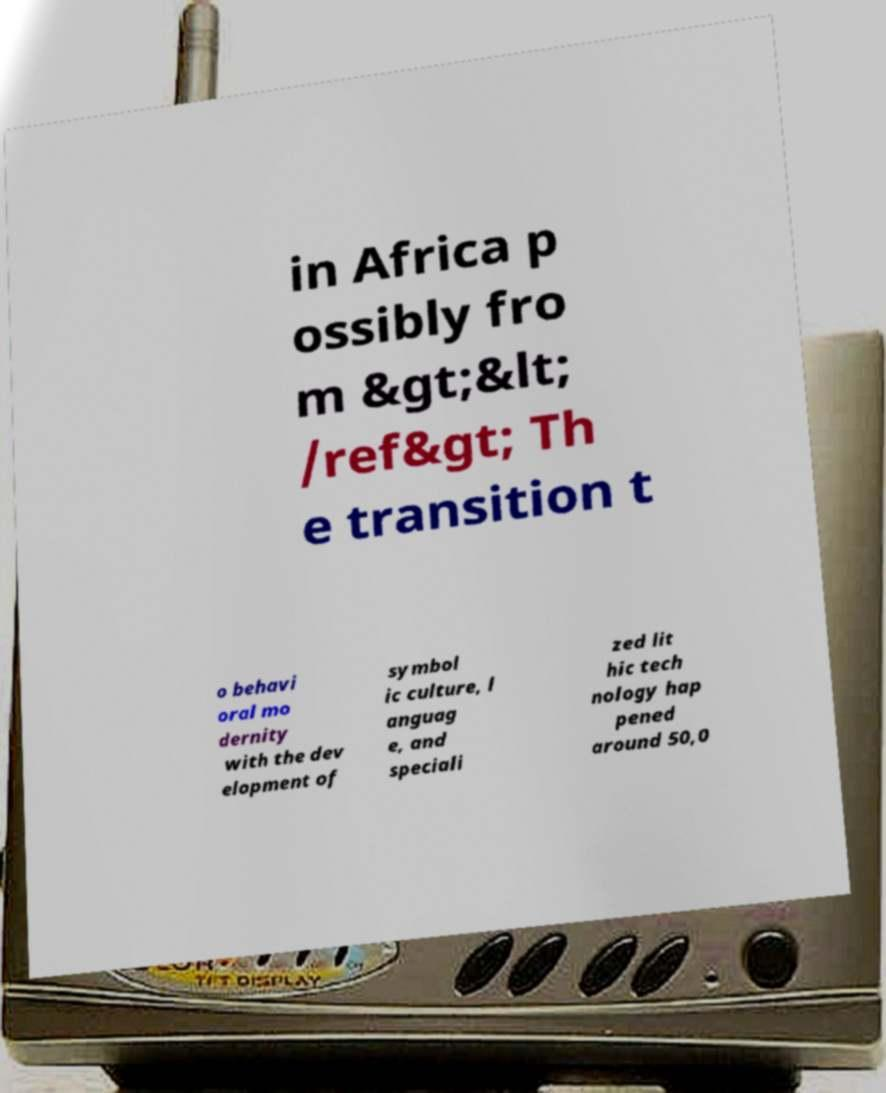Could you extract and type out the text from this image? in Africa p ossibly fro m &gt;&lt; /ref&gt; Th e transition t o behavi oral mo dernity with the dev elopment of symbol ic culture, l anguag e, and speciali zed lit hic tech nology hap pened around 50,0 